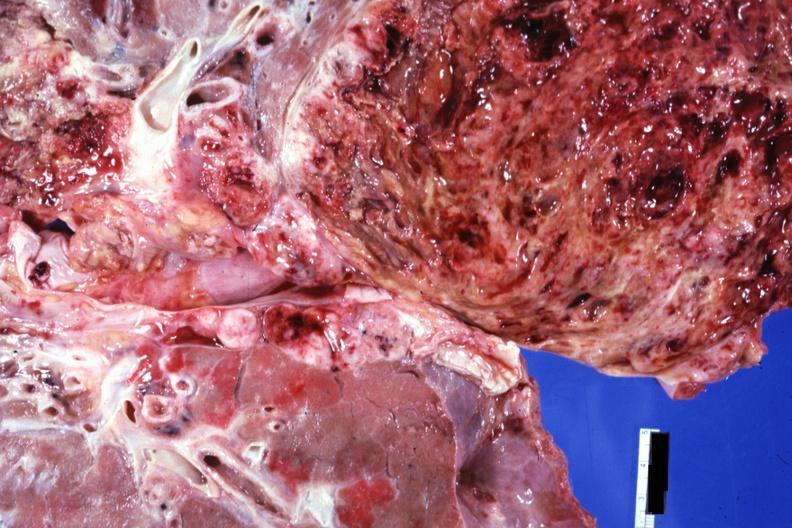does purulent sinusitis show rather close-up view of tumor cut surface?
Answer the question using a single word or phrase. No 